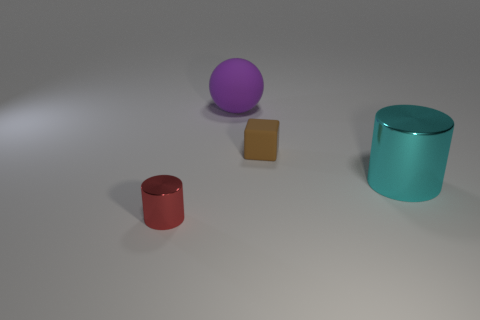There is a tiny block; does it have the same color as the cylinder that is right of the purple ball? No, the tiny block does not share the same color as the cylinder. The block is a tan or beige color, whereas the cylinder to the right of the purple ball is teal. 